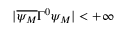<formula> <loc_0><loc_0><loc_500><loc_500>| \overline { { { \psi _ { M } } } } \Gamma ^ { 0 } \psi _ { M } | < + \infty</formula> 